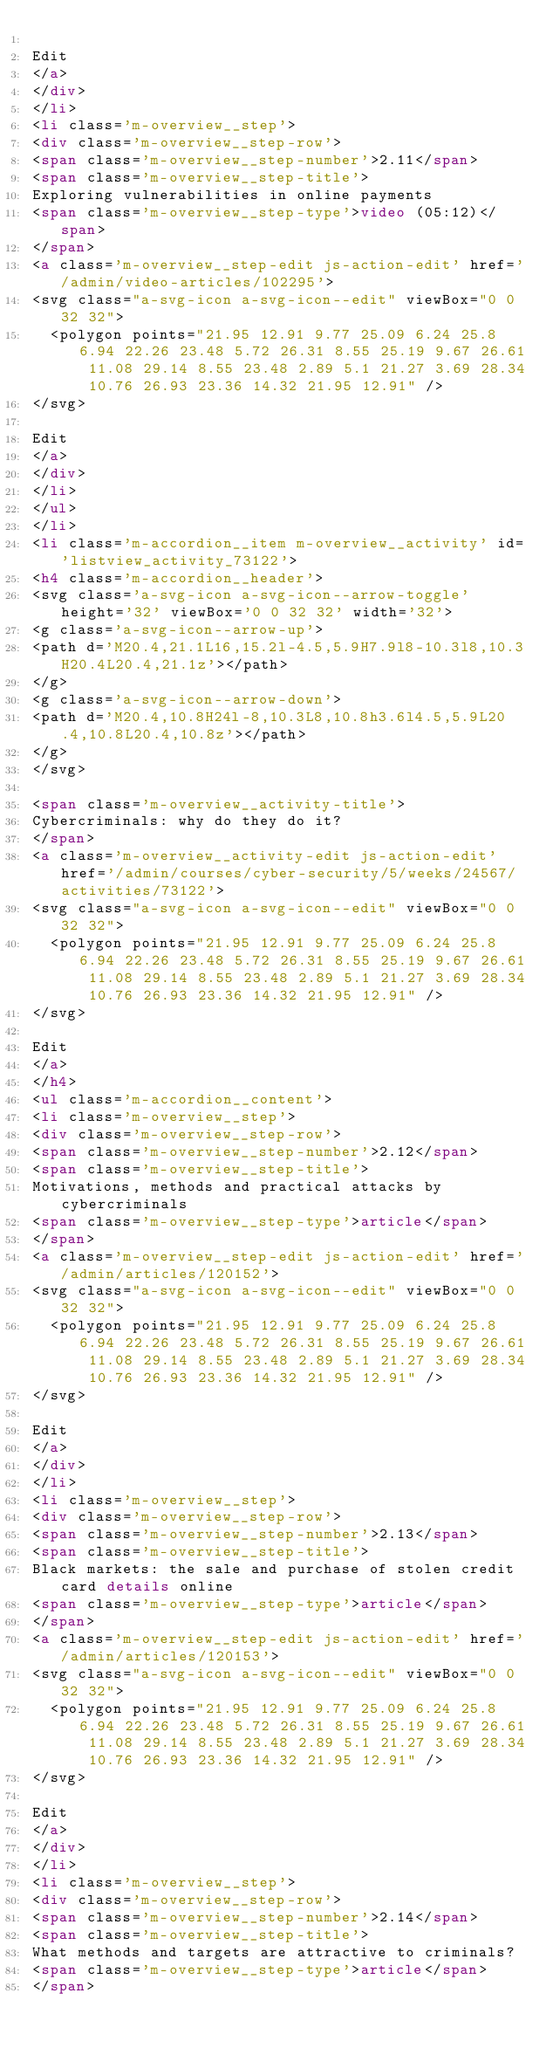Convert code to text. <code><loc_0><loc_0><loc_500><loc_500><_HTML_>
Edit
</a>
</div>
</li>
<li class='m-overview__step'>
<div class='m-overview__step-row'>
<span class='m-overview__step-number'>2.11</span>
<span class='m-overview__step-title'>
Exploring vulnerabilities in online payments
<span class='m-overview__step-type'>video (05:12)</span>
</span>
<a class='m-overview__step-edit js-action-edit' href='/admin/video-articles/102295'>
<svg class="a-svg-icon a-svg-icon--edit" viewBox="0 0 32 32">
  <polygon points="21.95 12.91 9.77 25.09 6.24 25.8 6.94 22.26 23.48 5.72 26.31 8.55 25.19 9.67 26.61 11.08 29.14 8.55 23.48 2.89 5.1 21.27 3.69 28.34 10.76 26.93 23.36 14.32 21.95 12.91" />
</svg>

Edit
</a>
</div>
</li>
</ul>
</li>
<li class='m-accordion__item m-overview__activity' id='listview_activity_73122'>
<h4 class='m-accordion__header'>
<svg class='a-svg-icon a-svg-icon--arrow-toggle' height='32' viewBox='0 0 32 32' width='32'>
<g class='a-svg-icon--arrow-up'>
<path d='M20.4,21.1L16,15.2l-4.5,5.9H7.9l8-10.3l8,10.3H20.4L20.4,21.1z'></path>
</g>
<g class='a-svg-icon--arrow-down'>
<path d='M20.4,10.8H24l-8,10.3L8,10.8h3.6l4.5,5.9L20.4,10.8L20.4,10.8z'></path>
</g>
</svg>

<span class='m-overview__activity-title'>
Cybercriminals: why do they do it?
</span>
<a class='m-overview__activity-edit js-action-edit' href='/admin/courses/cyber-security/5/weeks/24567/activities/73122'>
<svg class="a-svg-icon a-svg-icon--edit" viewBox="0 0 32 32">
  <polygon points="21.95 12.91 9.77 25.09 6.24 25.8 6.94 22.26 23.48 5.72 26.31 8.55 25.19 9.67 26.61 11.08 29.14 8.55 23.48 2.89 5.1 21.27 3.69 28.34 10.76 26.93 23.36 14.32 21.95 12.91" />
</svg>

Edit
</a>
</h4>
<ul class='m-accordion__content'>
<li class='m-overview__step'>
<div class='m-overview__step-row'>
<span class='m-overview__step-number'>2.12</span>
<span class='m-overview__step-title'>
Motivations, methods and practical attacks by cybercriminals
<span class='m-overview__step-type'>article</span>
</span>
<a class='m-overview__step-edit js-action-edit' href='/admin/articles/120152'>
<svg class="a-svg-icon a-svg-icon--edit" viewBox="0 0 32 32">
  <polygon points="21.95 12.91 9.77 25.09 6.24 25.8 6.94 22.26 23.48 5.72 26.31 8.55 25.19 9.67 26.61 11.08 29.14 8.55 23.48 2.89 5.1 21.27 3.69 28.34 10.76 26.93 23.36 14.32 21.95 12.91" />
</svg>

Edit
</a>
</div>
</li>
<li class='m-overview__step'>
<div class='m-overview__step-row'>
<span class='m-overview__step-number'>2.13</span>
<span class='m-overview__step-title'>
Black markets: the sale and purchase of stolen credit card details online
<span class='m-overview__step-type'>article</span>
</span>
<a class='m-overview__step-edit js-action-edit' href='/admin/articles/120153'>
<svg class="a-svg-icon a-svg-icon--edit" viewBox="0 0 32 32">
  <polygon points="21.95 12.91 9.77 25.09 6.24 25.8 6.94 22.26 23.48 5.72 26.31 8.55 25.19 9.67 26.61 11.08 29.14 8.55 23.48 2.89 5.1 21.27 3.69 28.34 10.76 26.93 23.36 14.32 21.95 12.91" />
</svg>

Edit
</a>
</div>
</li>
<li class='m-overview__step'>
<div class='m-overview__step-row'>
<span class='m-overview__step-number'>2.14</span>
<span class='m-overview__step-title'>
What methods and targets are attractive to criminals?
<span class='m-overview__step-type'>article</span>
</span></code> 